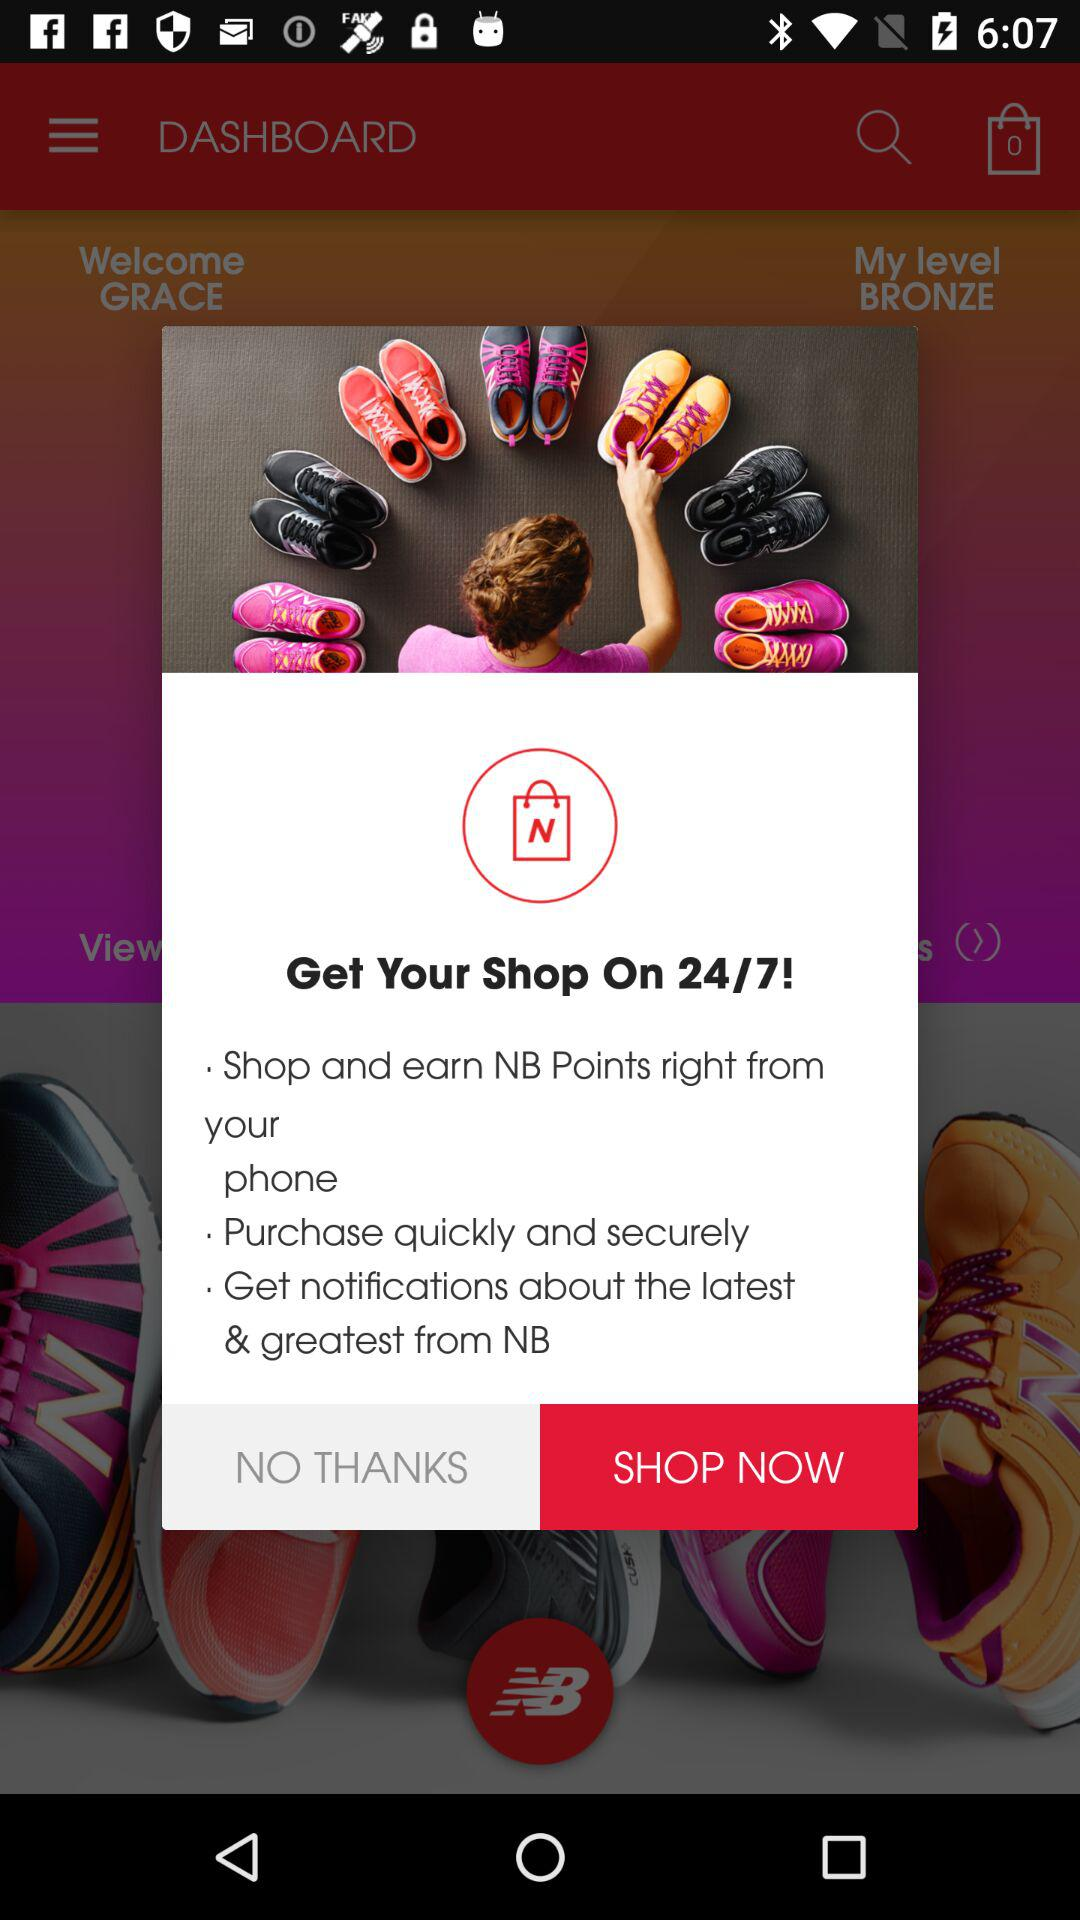When will the shop be open?
When the provided information is insufficient, respond with <no answer>. <no answer> 